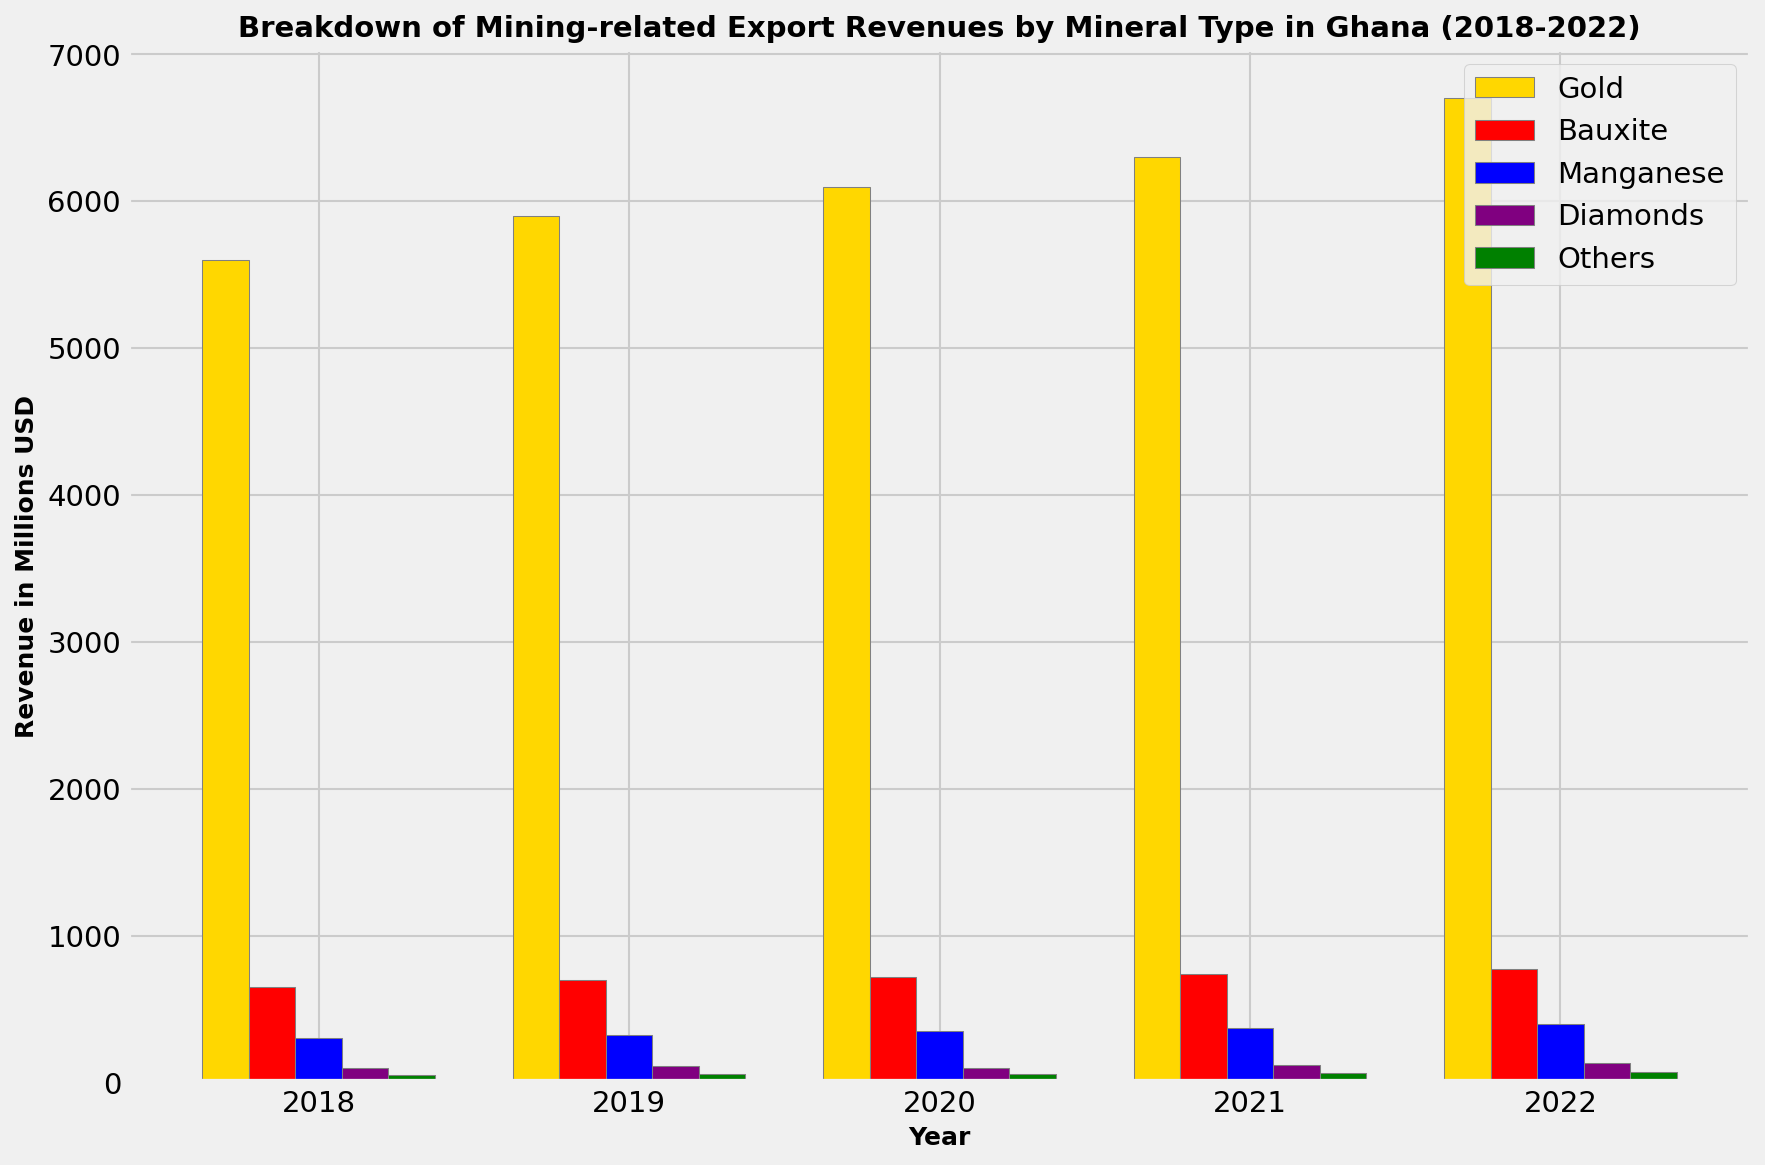What is the total revenue from mining-related exports in 2018? To find the total revenue for 2018, sum up the revenues from all mineral types in 2018: 5600 (Gold) + 650 (Bauxite) + 300 (Manganese) + 100 (Diamonds) + 50 (Others) = 6700 million USD
Answer: 6700 million USD Which mineral type had the highest revenue in 2020? By visually inspecting the height of the bars for 2020, Gold has the highest bar which corresponds to the highest revenue.
Answer: Gold How did the revenue from Bauxite change from 2018 to 2022? To find the change, subtract the revenue in 2018 from the revenue in 2022: 770 (2022) - 650 (2018) = 120 million USD.
Answer: Increased by 120 million USD In which year did Diamonds have the highest revenue? By comparing the bars representing Diamonds over the years, the highest bar is in 2022.
Answer: 2022 What is the average annual revenue from Manganese over the five-year period? Compute the average by summing the annual revenues and then dividing by the number of years: (300 + 320 + 350 + 370 + 400)/5 = 348 million USD.
Answer: 348 million USD Which mineral type shows the most consistent increase in revenue over the five years? By observing the trend lines for each mineral type, Gold shows a consistent increase every year.
Answer: Gold Compare the revenues of Manganese and Diamonds in 2019. Which one had higher revenue? By comparing the heights of the bars for Manganese and Diamonds in 2019, Manganese has a higher bar: 320 (Manganese) vs. 110 (Diamonds).
Answer: Manganese Which year experienced the highest total revenue from all mineral exports combined? The year with the highest total revenue is found by summing the individual revenues for each year and comparing: 6700 (2022) + 770 (2022) + 400 (2022) + 130 (2022) + 70 (2022) = 8070 million USD is the highest.
Answer: 2022 If the trend continues, which mineral is likely to show the highest increase in revenue next year? By observing the consistent increase and highest yearly increases, Gold is likely to show the highest increase.
Answer: Gold 